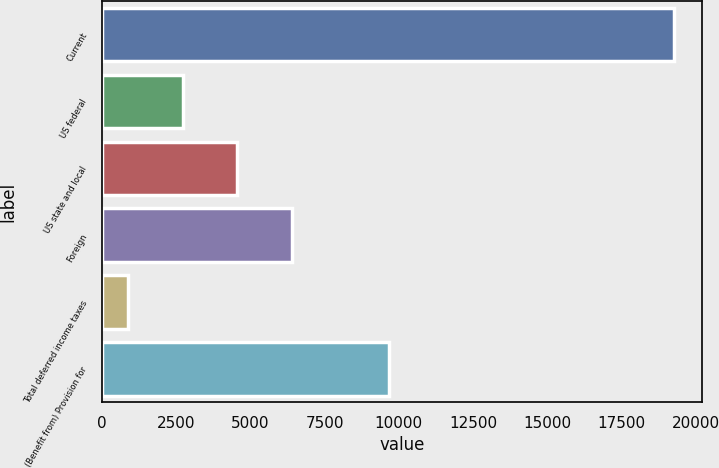Convert chart. <chart><loc_0><loc_0><loc_500><loc_500><bar_chart><fcel>Current<fcel>US federal<fcel>US state and local<fcel>Foreign<fcel>Total deferred income taxes<fcel>(Benefit from) Provision for<nl><fcel>19271<fcel>2720.9<fcel>4559.8<fcel>6398.7<fcel>882<fcel>9662<nl></chart> 